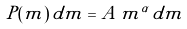<formula> <loc_0><loc_0><loc_500><loc_500>P ( m ) \, d m = A \, m ^ { \alpha } \, d m</formula> 